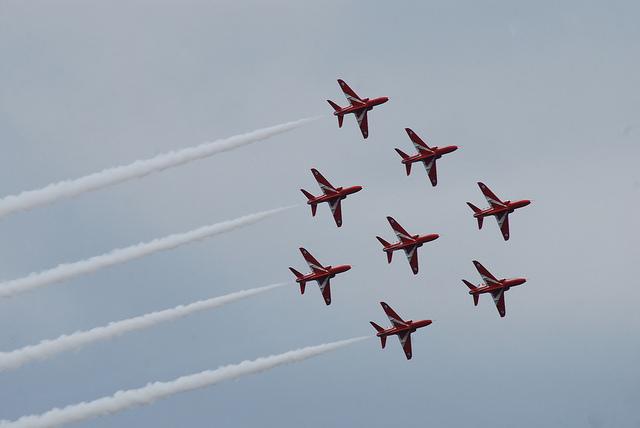How many airplanes are there?
Answer briefly. 8. Are these planes flying a formation?
Be succinct. Yes. How many planes are there?
Concise answer only. 8. Are more than half the jets emitting a visible trail?
Be succinct. No. Are these contrails?
Keep it brief. Yes. 